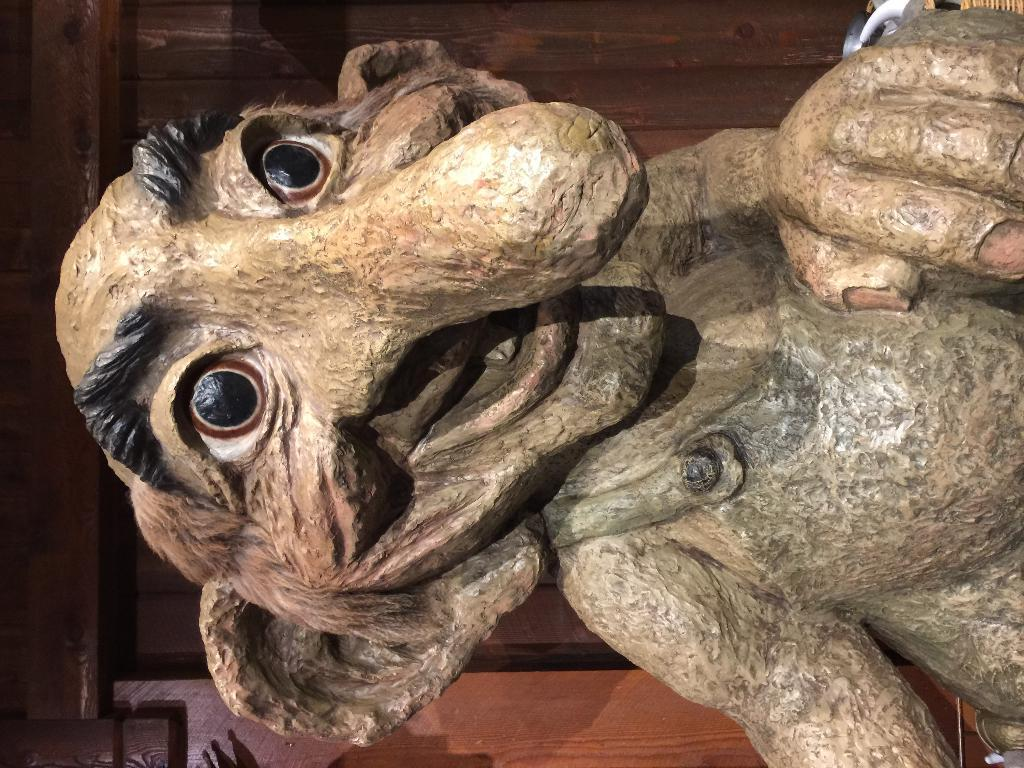What is the main subject of the image? There is a statue in the image that resembles an old man. What can be seen in the background of the image? There is a wooden wall and a door in the background of the image. What type of vegetation is present in the image? Leaves are present in the image. What is at the bottom of the image? There is a wall at the bottom of the image. What channel is the statue watching on the television in the image? There is no television present in the image; it features a statue of an old man and a wooden wall in the background. How many children are playing around the statue in the image? There are no children present in the image; it features a statue of an old man and a wooden wall in the background. 